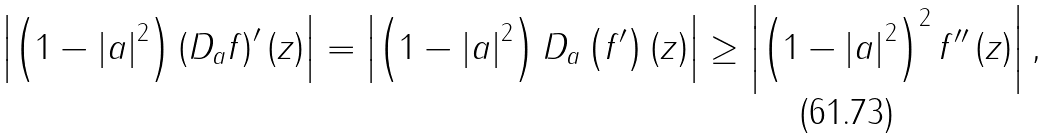Convert formula to latex. <formula><loc_0><loc_0><loc_500><loc_500>\left | \left ( 1 - \left | a \right | ^ { 2 } \right ) \left ( D _ { a } f \right ) ^ { \prime } \left ( z \right ) \right | = \left | \left ( 1 - \left | a \right | ^ { 2 } \right ) D _ { a } \left ( f ^ { \prime } \right ) \left ( z \right ) \right | \geq \left | \left ( 1 - \left | a \right | ^ { 2 } \right ) ^ { 2 } f ^ { \prime \prime } \left ( z \right ) \right | ,</formula> 